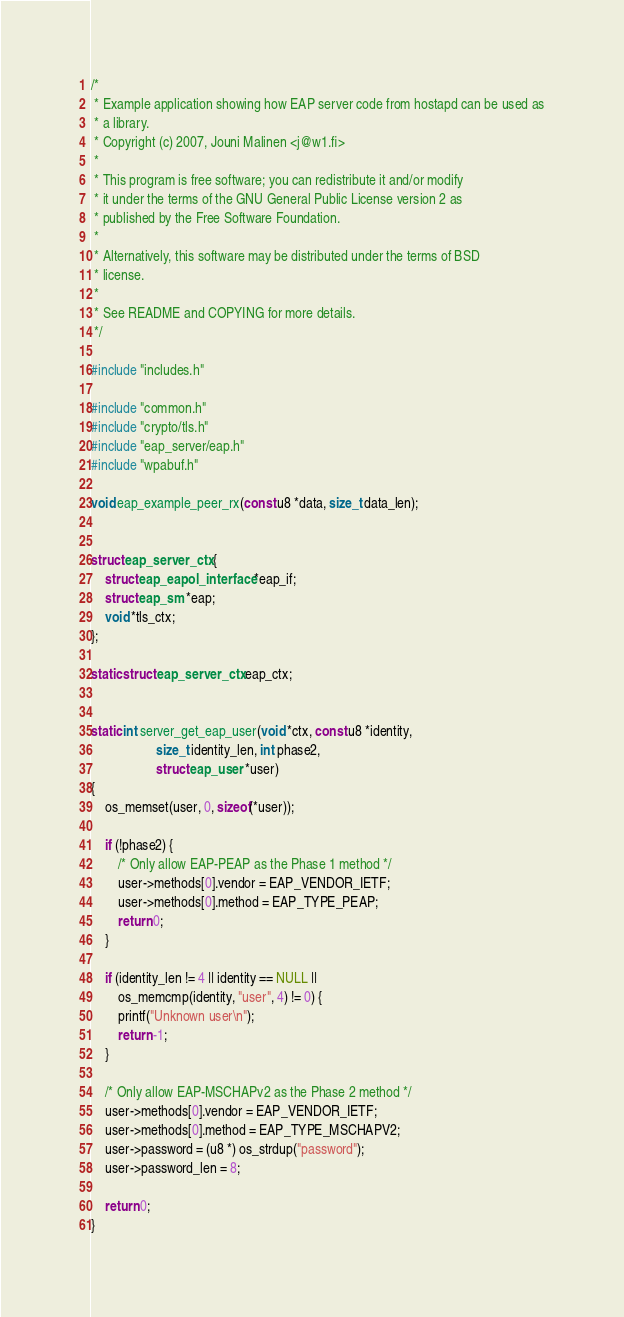<code> <loc_0><loc_0><loc_500><loc_500><_C_>/*
 * Example application showing how EAP server code from hostapd can be used as
 * a library.
 * Copyright (c) 2007, Jouni Malinen <j@w1.fi>
 *
 * This program is free software; you can redistribute it and/or modify
 * it under the terms of the GNU General Public License version 2 as
 * published by the Free Software Foundation.
 *
 * Alternatively, this software may be distributed under the terms of BSD
 * license.
 *
 * See README and COPYING for more details.
 */

#include "includes.h"

#include "common.h"
#include "crypto/tls.h"
#include "eap_server/eap.h"
#include "wpabuf.h"

void eap_example_peer_rx(const u8 *data, size_t data_len);


struct eap_server_ctx {
	struct eap_eapol_interface *eap_if;
	struct eap_sm *eap;
	void *tls_ctx;
};

static struct eap_server_ctx eap_ctx;


static int server_get_eap_user(void *ctx, const u8 *identity,
			       size_t identity_len, int phase2,
			       struct eap_user *user)
{
	os_memset(user, 0, sizeof(*user));

	if (!phase2) {
		/* Only allow EAP-PEAP as the Phase 1 method */
		user->methods[0].vendor = EAP_VENDOR_IETF;
		user->methods[0].method = EAP_TYPE_PEAP;
		return 0;
	}

	if (identity_len != 4 || identity == NULL ||
	    os_memcmp(identity, "user", 4) != 0) {
		printf("Unknown user\n");
		return -1;
	}

	/* Only allow EAP-MSCHAPv2 as the Phase 2 method */
	user->methods[0].vendor = EAP_VENDOR_IETF;
	user->methods[0].method = EAP_TYPE_MSCHAPV2;
	user->password = (u8 *) os_strdup("password");
	user->password_len = 8;

	return 0;
}

</code> 